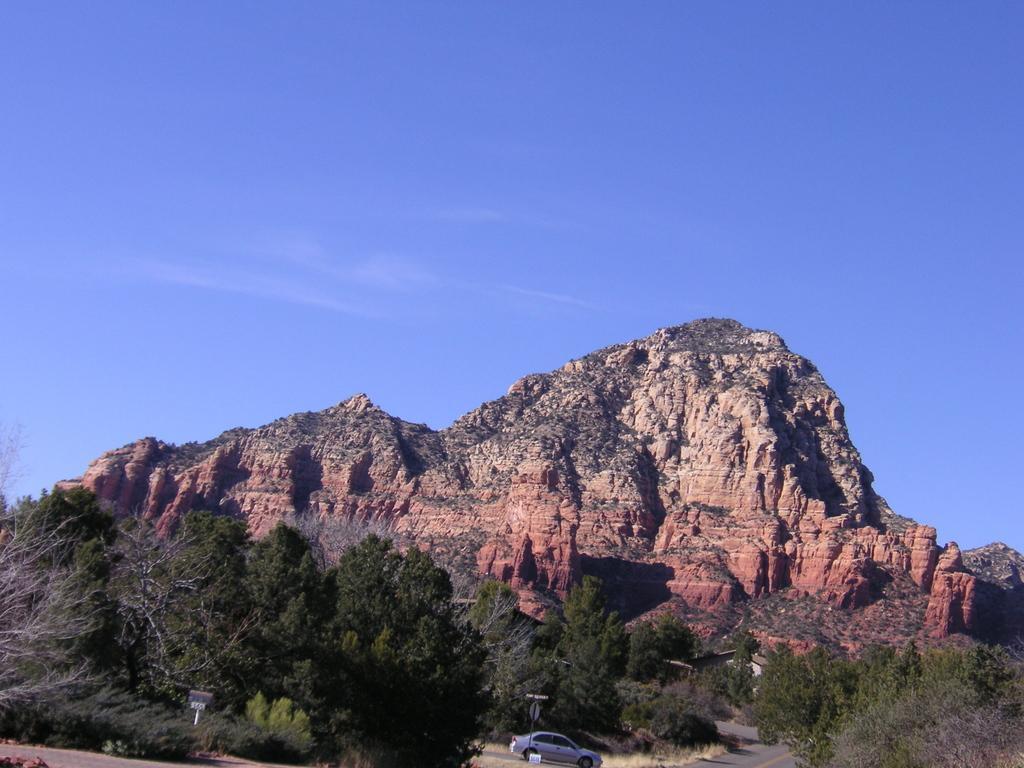Please provide a concise description of this image. Here we can see a car, poles, boards, grass, trees, road, and a mountain. In the background there is sky. 